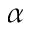<formula> <loc_0><loc_0><loc_500><loc_500>\alpha</formula> 